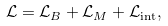Convert formula to latex. <formula><loc_0><loc_0><loc_500><loc_500>\mathcal { L } = \mathcal { L } _ { B } + \mathcal { L } _ { M } + \mathcal { L } _ { \text {int} } ,</formula> 